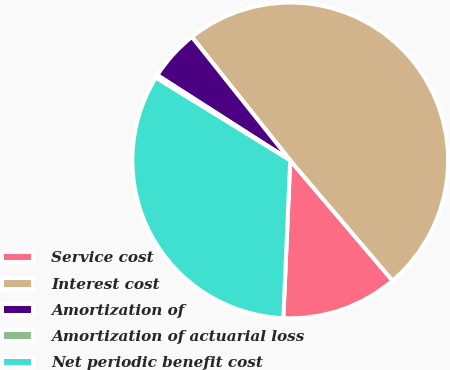<chart> <loc_0><loc_0><loc_500><loc_500><pie_chart><fcel>Service cost<fcel>Interest cost<fcel>Amortization of<fcel>Amortization of actuarial loss<fcel>Net periodic benefit cost<nl><fcel>11.92%<fcel>49.48%<fcel>5.22%<fcel>0.3%<fcel>33.08%<nl></chart> 